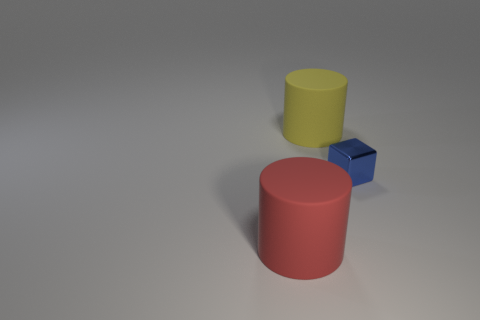Add 1 blue cubes. How many objects exist? 4 Subtract all blocks. How many objects are left? 2 Subtract all cylinders. Subtract all small blue metal things. How many objects are left? 0 Add 3 tiny blue metal cubes. How many tiny blue metal cubes are left? 4 Add 1 tiny brown things. How many tiny brown things exist? 1 Subtract 0 purple blocks. How many objects are left? 3 